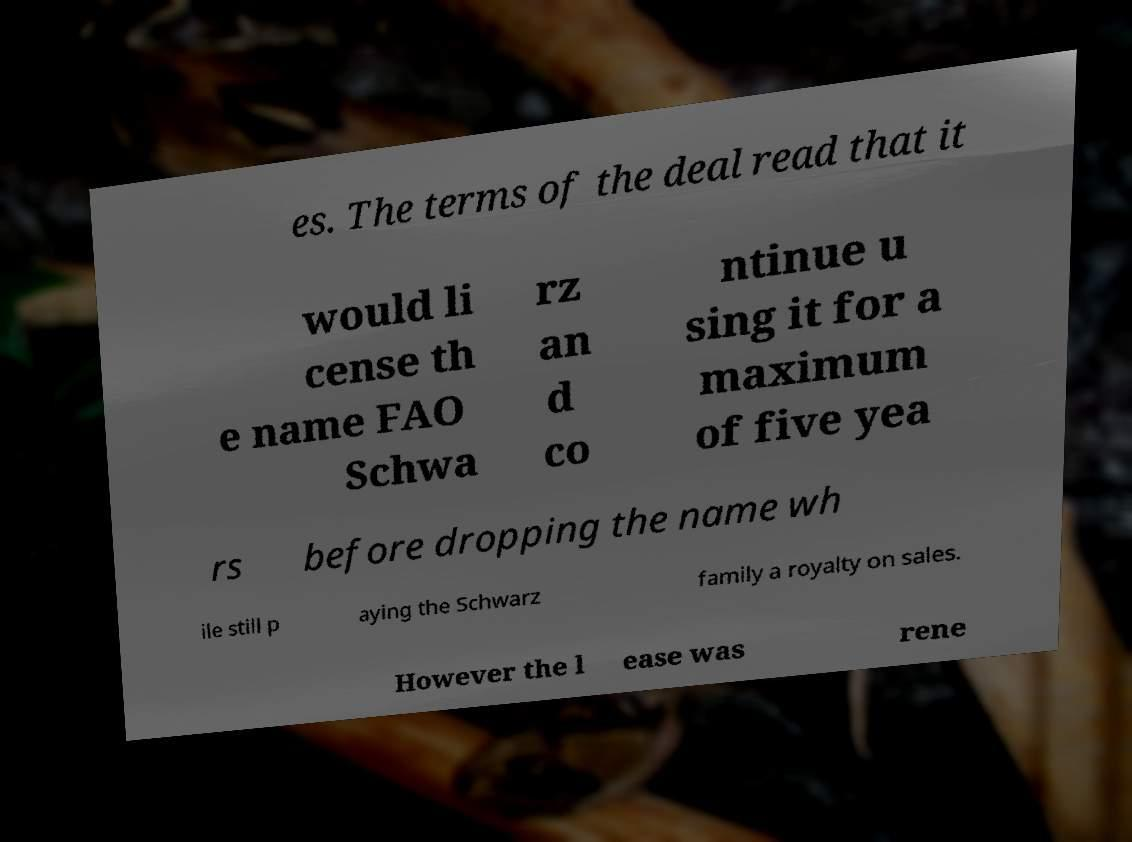Please identify and transcribe the text found in this image. es. The terms of the deal read that it would li cense th e name FAO Schwa rz an d co ntinue u sing it for a maximum of five yea rs before dropping the name wh ile still p aying the Schwarz family a royalty on sales. However the l ease was rene 